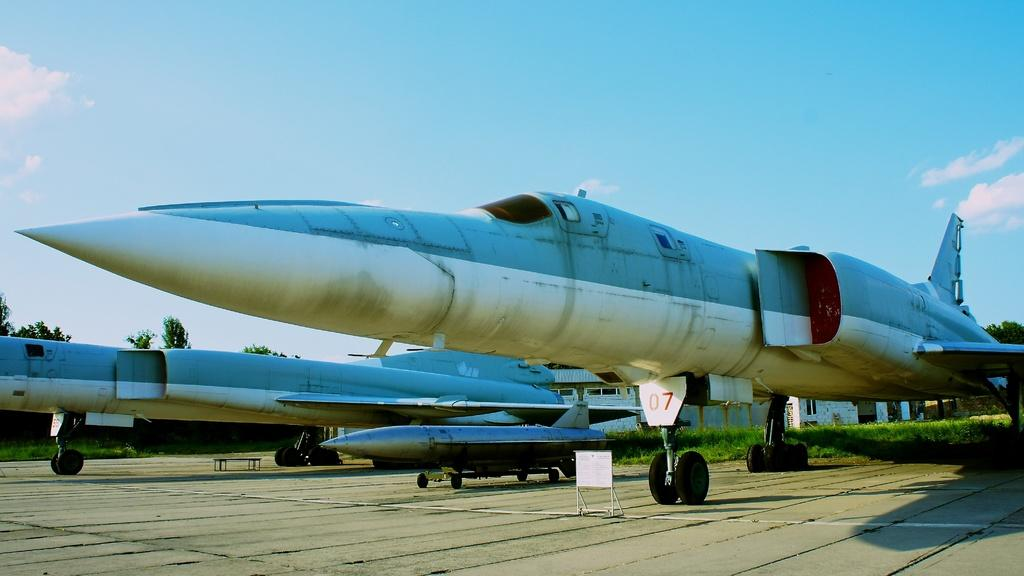Provide a one-sentence caption for the provided image. An airplane with 07 above the wheel of the plane. 